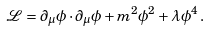<formula> <loc_0><loc_0><loc_500><loc_500>\mathcal { L } = \partial _ { \mu } \phi \cdot \partial _ { \mu } \phi + m ^ { 2 } \phi ^ { 2 } + \lambda \phi ^ { 4 } \, .</formula> 